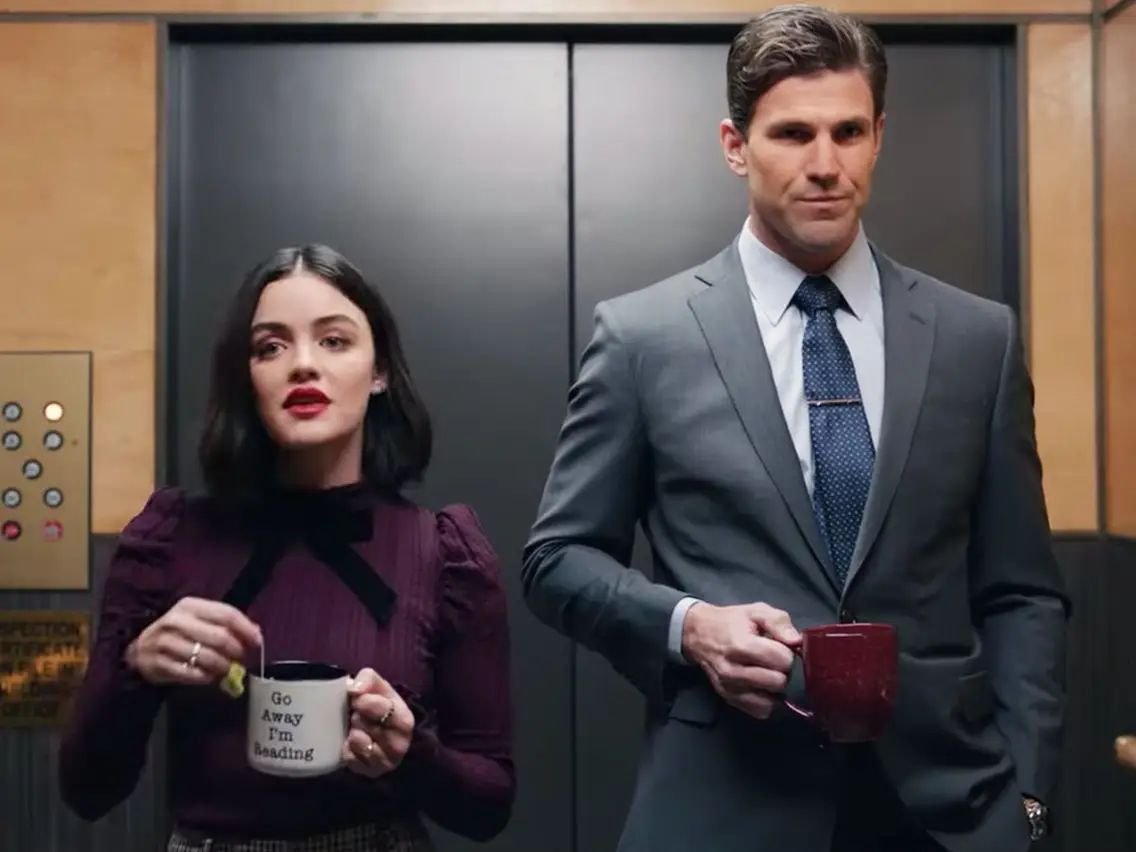Imagine this image is a scene from a sci-fi thriller. What storyline could this image fit into? In a futuristic sci-fi thriller set in a corporate dystopia, this image could be from a scene where Lucy Hale's character, a rebel covertly working within the corporation, is confronted by a high-ranking executive. As they both ride the elevator, Lucy, holding her mug with the hidden message, tries to gauge the extent of his knowledge about her secret activities. The executive, stone-faced and authoritative, subtly warns her that they are closely monitoring employees for any signs of dissent, leaving Lucy to ponder her next move amidst growing tension. If this image belonged in a comedy sitcom, what might the humorous situation be? In a comedy sitcom, this scene could revolve around a classic misunderstanding. Lucy Hale, holding her coffee mug with a sassy message, enters the elevator with her boss right after an embarrassing karaoke performance at the office party. She’s surprised to find herself facing him, and there’s an awkward silence as the elevator begins to move. Just then, the elevator breaks down, trapping them together. The boss, trying to keep a straight face but failing, says, 'Great performance last night. Quite the... unique rendition of 'I Will Survive.' Lucy, mortified, stammers, 'Yeah, about that... it was supposed to be a surprise!' leading to a hilarious and awkward dialogue about office antics and hidden talents. 